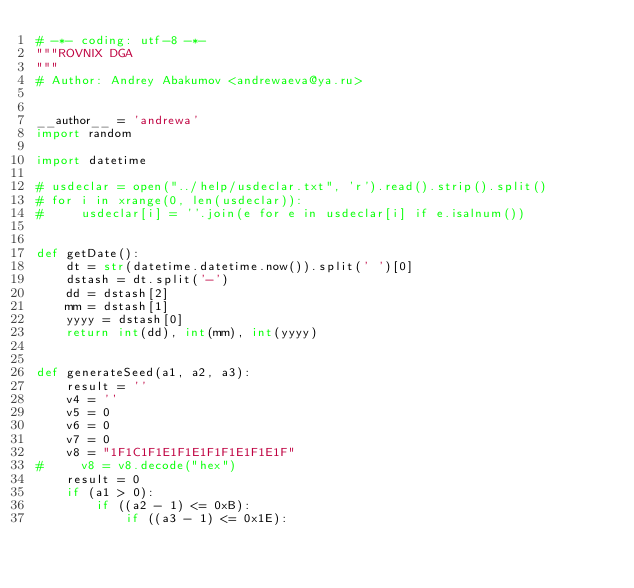Convert code to text. <code><loc_0><loc_0><loc_500><loc_500><_Python_># -*- coding: utf-8 -*-
"""ROVNIX DGA
"""
# Author: Andrey Abakumov <andrewaeva@ya.ru>


__author__ = 'andrewa'
import random

import datetime

# usdeclar = open("../help/usdeclar.txt", 'r').read().strip().split()
# for i in xrange(0, len(usdeclar)):
#     usdeclar[i] = ''.join(e for e in usdeclar[i] if e.isalnum())


def getDate():
    dt = str(datetime.datetime.now()).split(' ')[0]
    dstash = dt.split('-')
    dd = dstash[2]
    mm = dstash[1]
    yyyy = dstash[0]
    return int(dd), int(mm), int(yyyy)


def generateSeed(a1, a2, a3):
    result = ''
    v4 = ''
    v5 = 0
    v6 = 0
    v7 = 0
    v8 = "1F1C1F1E1F1E1F1F1E1F1E1F"
#     v8 = v8.decode("hex")
    result = 0
    if (a1 > 0):
        if ((a2 - 1) <= 0xB):
            if ((a3 - 1) <= 0x1E):</code> 